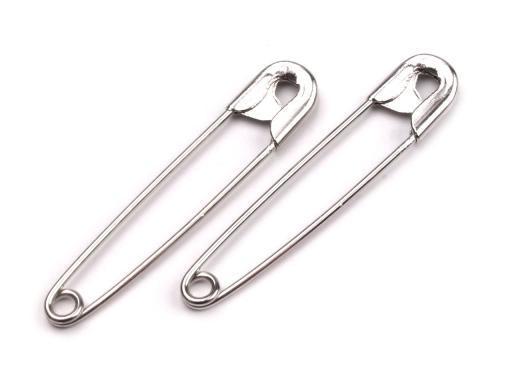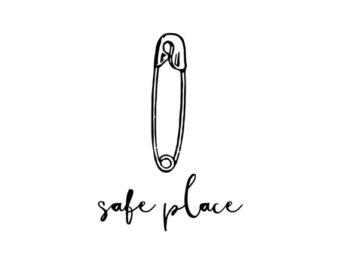The first image is the image on the left, the second image is the image on the right. Evaluate the accuracy of this statement regarding the images: "There are more pins shown in the image on the left.". Is it true? Answer yes or no. Yes. 